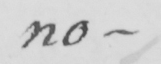Can you read and transcribe this handwriting? no- 